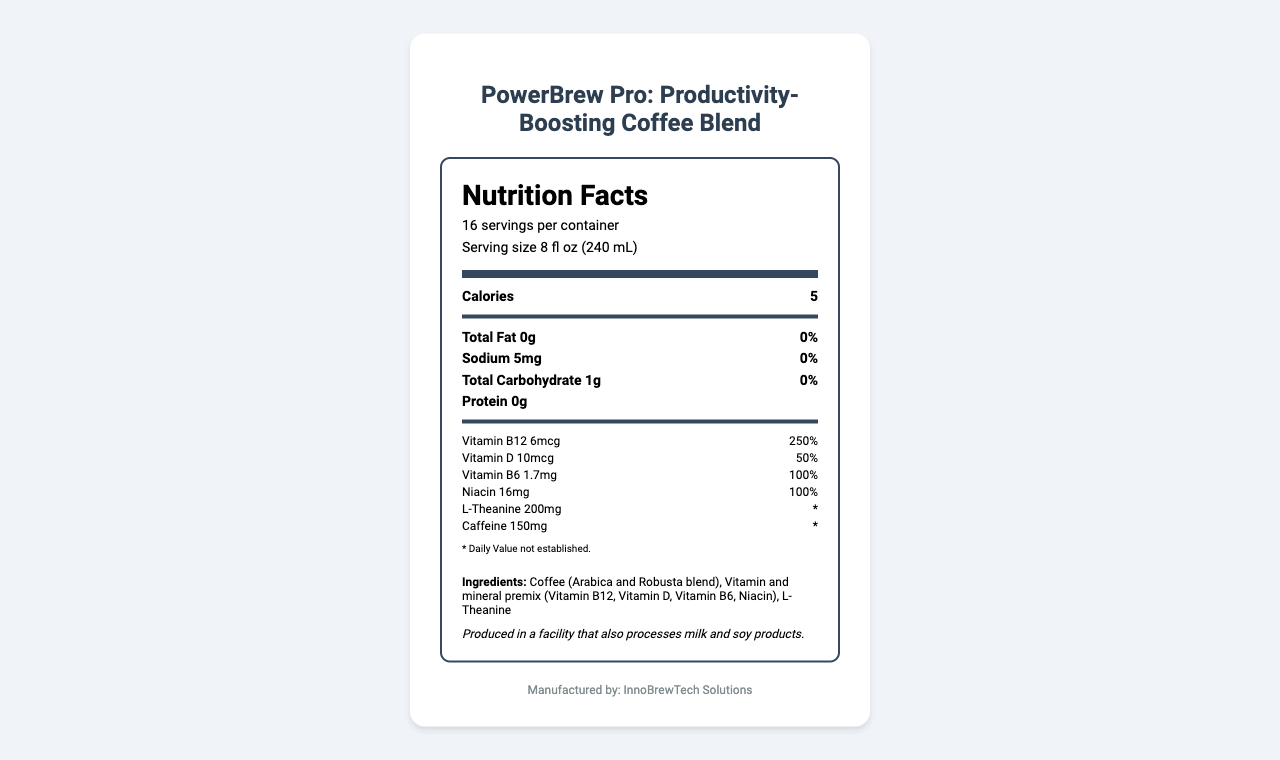what is the serving size for PowerBrew Pro? The serving size is stated as "8 fl oz (240 mL)" at the top of the nutrition label.
Answer: 8 fl oz (240 mL) how many servings are in one container of PowerBrew Pro? The label indicates that there are 16 servings per container.
Answer: 16 servings how many calories are in one serving of PowerBrew Pro? The nutrition label lists the calories per serving as 5.
Answer: 5 calories how much sodium is in a single serving? The amount of sodium per serving is listed as 5mg on the label.
Answer: 5mg which vitamin has the highest daily value percentage per serving of PowerBrew Pro? Vitamin B12 shows a daily value percentage of 250%, which is the highest among the listed vitamins and minerals.
Answer: Vitamin B12 how much caffeine is in a single serving of PowerBrew Pro? The amount of caffeine per serving is listed as 150mg.
Answer: 150mg what is the total cost per serving for manufacturing PowerBrew Pro? The total cost per serving is listed as $0.55, which includes all component costs.
Answer: $0.55 which of the following vitamins is not included in PowerBrew Pro?
A. Vitamin C
B. Vitamin D
C. Vitamin B12 The vitamins included are Vitamin B12, Vitamin D, Vitamin B6, and Niacin. Vitamin C is not mentioned.
Answer: A. Vitamin C what is the primary purpose of PowerBrew Pro according to the document?
A. Fitness Enhancement
B. Weight Loss
C. Productivity Boost The product is described as a "Productivity-Boosting Coffee Blend."
Answer: C. Productivity Boost does this product contain any allergens? The allergen information specifies that the product is produced in a facility that also processes milk and soy products.
Answer: Yes summarize the main idea of the PowerBrew Pro document. The summary captures the key aspects: product description, nutrition facts, manufacturing costs, financial details, and regulatory guidance provided in the document.
Answer: PowerBrew Pro is a vitamin-fortified coffee blend designed to boost productivity. The nutrition label details serving size, calories, macronutrients, vitamins, and other ingredients. The document includes a manufacturing cost analysis, bulk purchasing recommendations, financial projections, cost-efficient manufacturing tips, and regulatory compliance notes. what is the source of the vitamin and mineral premix in the PowerBrew Pro? The document does not specify the source of the vitamin and mineral premix; it only lists its presence in the ingredients.
Answer: Cannot be determined 